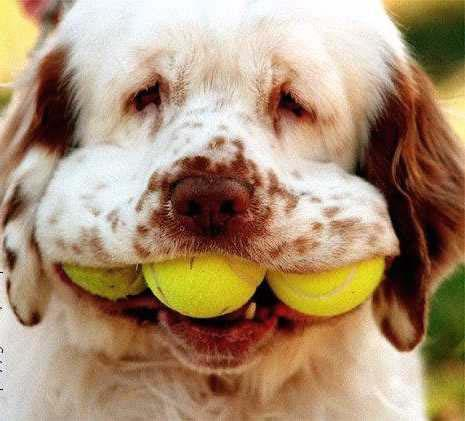What material is used to make the balls in the dogs mouth? rubber 